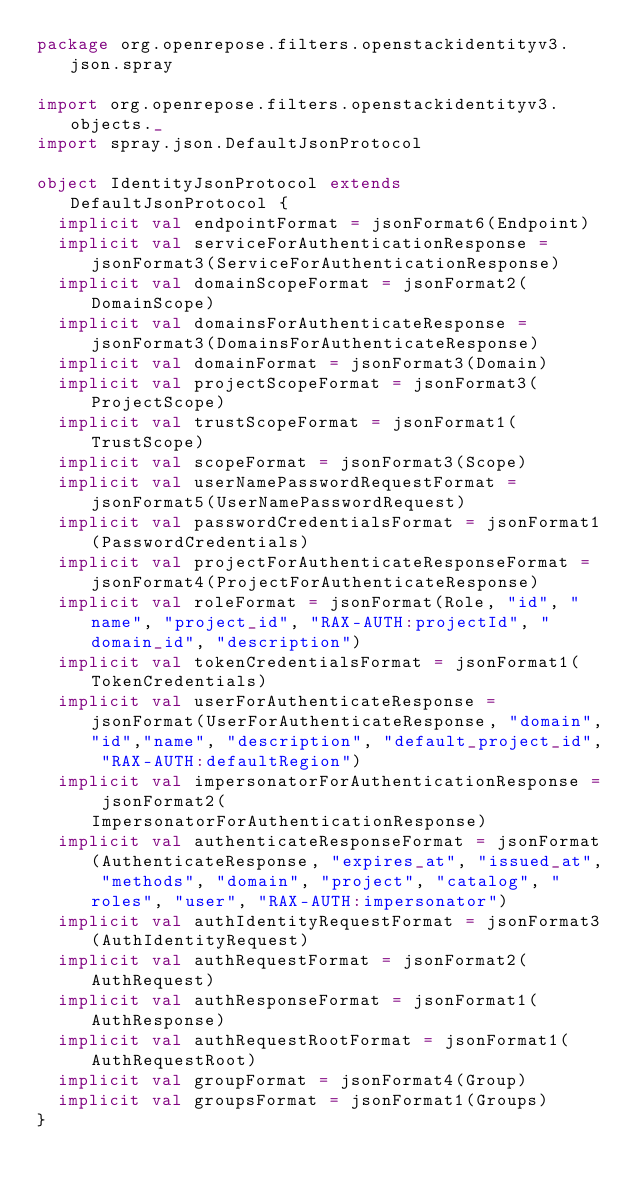<code> <loc_0><loc_0><loc_500><loc_500><_Scala_>package org.openrepose.filters.openstackidentityv3.json.spray

import org.openrepose.filters.openstackidentityv3.objects._
import spray.json.DefaultJsonProtocol

object IdentityJsonProtocol extends DefaultJsonProtocol {
  implicit val endpointFormat = jsonFormat6(Endpoint)
  implicit val serviceForAuthenticationResponse = jsonFormat3(ServiceForAuthenticationResponse)
  implicit val domainScopeFormat = jsonFormat2(DomainScope)
  implicit val domainsForAuthenticateResponse = jsonFormat3(DomainsForAuthenticateResponse)
  implicit val domainFormat = jsonFormat3(Domain)
  implicit val projectScopeFormat = jsonFormat3(ProjectScope)
  implicit val trustScopeFormat = jsonFormat1(TrustScope)
  implicit val scopeFormat = jsonFormat3(Scope)
  implicit val userNamePasswordRequestFormat = jsonFormat5(UserNamePasswordRequest)
  implicit val passwordCredentialsFormat = jsonFormat1(PasswordCredentials)
  implicit val projectForAuthenticateResponseFormat = jsonFormat4(ProjectForAuthenticateResponse)
  implicit val roleFormat = jsonFormat(Role, "id", "name", "project_id", "RAX-AUTH:projectId", "domain_id", "description")
  implicit val tokenCredentialsFormat = jsonFormat1(TokenCredentials)
  implicit val userForAuthenticateResponse = jsonFormat(UserForAuthenticateResponse, "domain","id","name", "description", "default_project_id", "RAX-AUTH:defaultRegion")
  implicit val impersonatorForAuthenticationResponse = jsonFormat2(ImpersonatorForAuthenticationResponse)
  implicit val authenticateResponseFormat = jsonFormat(AuthenticateResponse, "expires_at", "issued_at", "methods", "domain", "project", "catalog", "roles", "user", "RAX-AUTH:impersonator")
  implicit val authIdentityRequestFormat = jsonFormat3(AuthIdentityRequest)
  implicit val authRequestFormat = jsonFormat2(AuthRequest)
  implicit val authResponseFormat = jsonFormat1(AuthResponse)
  implicit val authRequestRootFormat = jsonFormat1(AuthRequestRoot)
  implicit val groupFormat = jsonFormat4(Group)
  implicit val groupsFormat = jsonFormat1(Groups)
}
</code> 